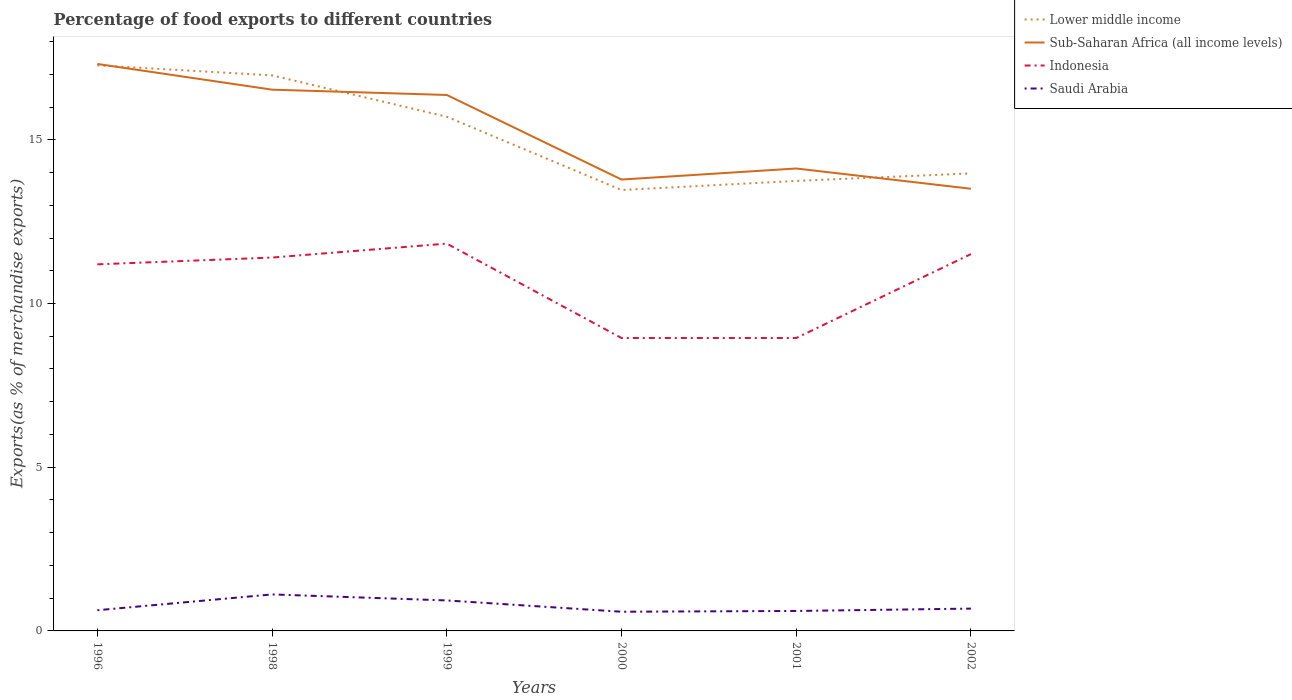Is the number of lines equal to the number of legend labels?
Offer a terse response. Yes. Across all years, what is the maximum percentage of exports to different countries in Indonesia?
Give a very brief answer. 8.95. In which year was the percentage of exports to different countries in Sub-Saharan Africa (all income levels) maximum?
Ensure brevity in your answer.  2002. What is the total percentage of exports to different countries in Sub-Saharan Africa (all income levels) in the graph?
Offer a very short reply. 3.19. What is the difference between the highest and the second highest percentage of exports to different countries in Lower middle income?
Ensure brevity in your answer.  3.81. Is the percentage of exports to different countries in Saudi Arabia strictly greater than the percentage of exports to different countries in Indonesia over the years?
Provide a short and direct response. Yes. How many lines are there?
Keep it short and to the point. 4. How many years are there in the graph?
Keep it short and to the point. 6. Are the values on the major ticks of Y-axis written in scientific E-notation?
Your answer should be very brief. No. Does the graph contain any zero values?
Offer a terse response. No. Does the graph contain grids?
Your response must be concise. No. Where does the legend appear in the graph?
Your answer should be compact. Top right. How many legend labels are there?
Provide a short and direct response. 4. How are the legend labels stacked?
Your response must be concise. Vertical. What is the title of the graph?
Provide a succinct answer. Percentage of food exports to different countries. Does "Tanzania" appear as one of the legend labels in the graph?
Give a very brief answer. No. What is the label or title of the Y-axis?
Keep it short and to the point. Exports(as % of merchandise exports). What is the Exports(as % of merchandise exports) of Lower middle income in 1996?
Keep it short and to the point. 17.27. What is the Exports(as % of merchandise exports) of Sub-Saharan Africa (all income levels) in 1996?
Give a very brief answer. 17.32. What is the Exports(as % of merchandise exports) in Indonesia in 1996?
Give a very brief answer. 11.2. What is the Exports(as % of merchandise exports) in Saudi Arabia in 1996?
Keep it short and to the point. 0.63. What is the Exports(as % of merchandise exports) of Lower middle income in 1998?
Offer a very short reply. 16.97. What is the Exports(as % of merchandise exports) in Sub-Saharan Africa (all income levels) in 1998?
Offer a terse response. 16.53. What is the Exports(as % of merchandise exports) of Indonesia in 1998?
Your answer should be very brief. 11.4. What is the Exports(as % of merchandise exports) of Saudi Arabia in 1998?
Provide a succinct answer. 1.11. What is the Exports(as % of merchandise exports) of Lower middle income in 1999?
Ensure brevity in your answer.  15.7. What is the Exports(as % of merchandise exports) of Sub-Saharan Africa (all income levels) in 1999?
Offer a very short reply. 16.37. What is the Exports(as % of merchandise exports) in Indonesia in 1999?
Provide a short and direct response. 11.83. What is the Exports(as % of merchandise exports) in Saudi Arabia in 1999?
Ensure brevity in your answer.  0.93. What is the Exports(as % of merchandise exports) in Lower middle income in 2000?
Your answer should be very brief. 13.47. What is the Exports(as % of merchandise exports) of Sub-Saharan Africa (all income levels) in 2000?
Provide a short and direct response. 13.79. What is the Exports(as % of merchandise exports) in Indonesia in 2000?
Provide a short and direct response. 8.95. What is the Exports(as % of merchandise exports) in Saudi Arabia in 2000?
Your response must be concise. 0.59. What is the Exports(as % of merchandise exports) of Lower middle income in 2001?
Ensure brevity in your answer.  13.74. What is the Exports(as % of merchandise exports) in Sub-Saharan Africa (all income levels) in 2001?
Provide a short and direct response. 14.12. What is the Exports(as % of merchandise exports) of Indonesia in 2001?
Make the answer very short. 8.95. What is the Exports(as % of merchandise exports) in Saudi Arabia in 2001?
Your answer should be very brief. 0.61. What is the Exports(as % of merchandise exports) in Lower middle income in 2002?
Give a very brief answer. 13.97. What is the Exports(as % of merchandise exports) in Sub-Saharan Africa (all income levels) in 2002?
Offer a very short reply. 13.5. What is the Exports(as % of merchandise exports) of Indonesia in 2002?
Your response must be concise. 11.51. What is the Exports(as % of merchandise exports) in Saudi Arabia in 2002?
Keep it short and to the point. 0.68. Across all years, what is the maximum Exports(as % of merchandise exports) of Lower middle income?
Ensure brevity in your answer.  17.27. Across all years, what is the maximum Exports(as % of merchandise exports) in Sub-Saharan Africa (all income levels)?
Offer a terse response. 17.32. Across all years, what is the maximum Exports(as % of merchandise exports) of Indonesia?
Ensure brevity in your answer.  11.83. Across all years, what is the maximum Exports(as % of merchandise exports) in Saudi Arabia?
Provide a succinct answer. 1.11. Across all years, what is the minimum Exports(as % of merchandise exports) of Lower middle income?
Your response must be concise. 13.47. Across all years, what is the minimum Exports(as % of merchandise exports) of Sub-Saharan Africa (all income levels)?
Offer a terse response. 13.5. Across all years, what is the minimum Exports(as % of merchandise exports) in Indonesia?
Keep it short and to the point. 8.95. Across all years, what is the minimum Exports(as % of merchandise exports) of Saudi Arabia?
Offer a very short reply. 0.59. What is the total Exports(as % of merchandise exports) of Lower middle income in the graph?
Your response must be concise. 91.13. What is the total Exports(as % of merchandise exports) in Sub-Saharan Africa (all income levels) in the graph?
Offer a very short reply. 91.63. What is the total Exports(as % of merchandise exports) in Indonesia in the graph?
Provide a succinct answer. 63.83. What is the total Exports(as % of merchandise exports) in Saudi Arabia in the graph?
Make the answer very short. 4.56. What is the difference between the Exports(as % of merchandise exports) in Lower middle income in 1996 and that in 1998?
Keep it short and to the point. 0.31. What is the difference between the Exports(as % of merchandise exports) of Sub-Saharan Africa (all income levels) in 1996 and that in 1998?
Give a very brief answer. 0.78. What is the difference between the Exports(as % of merchandise exports) of Indonesia in 1996 and that in 1998?
Provide a short and direct response. -0.21. What is the difference between the Exports(as % of merchandise exports) of Saudi Arabia in 1996 and that in 1998?
Your answer should be very brief. -0.48. What is the difference between the Exports(as % of merchandise exports) of Lower middle income in 1996 and that in 1999?
Your response must be concise. 1.57. What is the difference between the Exports(as % of merchandise exports) of Sub-Saharan Africa (all income levels) in 1996 and that in 1999?
Provide a succinct answer. 0.95. What is the difference between the Exports(as % of merchandise exports) of Indonesia in 1996 and that in 1999?
Offer a very short reply. -0.63. What is the difference between the Exports(as % of merchandise exports) in Saudi Arabia in 1996 and that in 1999?
Make the answer very short. -0.3. What is the difference between the Exports(as % of merchandise exports) of Lower middle income in 1996 and that in 2000?
Your answer should be compact. 3.81. What is the difference between the Exports(as % of merchandise exports) of Sub-Saharan Africa (all income levels) in 1996 and that in 2000?
Make the answer very short. 3.53. What is the difference between the Exports(as % of merchandise exports) in Indonesia in 1996 and that in 2000?
Keep it short and to the point. 2.25. What is the difference between the Exports(as % of merchandise exports) in Saudi Arabia in 1996 and that in 2000?
Offer a very short reply. 0.05. What is the difference between the Exports(as % of merchandise exports) of Lower middle income in 1996 and that in 2001?
Give a very brief answer. 3.53. What is the difference between the Exports(as % of merchandise exports) of Sub-Saharan Africa (all income levels) in 1996 and that in 2001?
Offer a terse response. 3.19. What is the difference between the Exports(as % of merchandise exports) of Indonesia in 1996 and that in 2001?
Provide a succinct answer. 2.25. What is the difference between the Exports(as % of merchandise exports) of Saudi Arabia in 1996 and that in 2001?
Make the answer very short. 0.02. What is the difference between the Exports(as % of merchandise exports) in Sub-Saharan Africa (all income levels) in 1996 and that in 2002?
Your response must be concise. 3.81. What is the difference between the Exports(as % of merchandise exports) in Indonesia in 1996 and that in 2002?
Provide a succinct answer. -0.31. What is the difference between the Exports(as % of merchandise exports) in Saudi Arabia in 1996 and that in 2002?
Your answer should be compact. -0.05. What is the difference between the Exports(as % of merchandise exports) in Lower middle income in 1998 and that in 1999?
Keep it short and to the point. 1.26. What is the difference between the Exports(as % of merchandise exports) in Sub-Saharan Africa (all income levels) in 1998 and that in 1999?
Ensure brevity in your answer.  0.16. What is the difference between the Exports(as % of merchandise exports) in Indonesia in 1998 and that in 1999?
Offer a terse response. -0.43. What is the difference between the Exports(as % of merchandise exports) in Saudi Arabia in 1998 and that in 1999?
Make the answer very short. 0.18. What is the difference between the Exports(as % of merchandise exports) in Lower middle income in 1998 and that in 2000?
Provide a short and direct response. 3.5. What is the difference between the Exports(as % of merchandise exports) of Sub-Saharan Africa (all income levels) in 1998 and that in 2000?
Ensure brevity in your answer.  2.75. What is the difference between the Exports(as % of merchandise exports) of Indonesia in 1998 and that in 2000?
Provide a succinct answer. 2.46. What is the difference between the Exports(as % of merchandise exports) in Saudi Arabia in 1998 and that in 2000?
Keep it short and to the point. 0.53. What is the difference between the Exports(as % of merchandise exports) in Lower middle income in 1998 and that in 2001?
Offer a very short reply. 3.22. What is the difference between the Exports(as % of merchandise exports) in Sub-Saharan Africa (all income levels) in 1998 and that in 2001?
Give a very brief answer. 2.41. What is the difference between the Exports(as % of merchandise exports) in Indonesia in 1998 and that in 2001?
Provide a succinct answer. 2.46. What is the difference between the Exports(as % of merchandise exports) in Saudi Arabia in 1998 and that in 2001?
Give a very brief answer. 0.51. What is the difference between the Exports(as % of merchandise exports) in Lower middle income in 1998 and that in 2002?
Offer a very short reply. 2.99. What is the difference between the Exports(as % of merchandise exports) in Sub-Saharan Africa (all income levels) in 1998 and that in 2002?
Your answer should be compact. 3.03. What is the difference between the Exports(as % of merchandise exports) of Indonesia in 1998 and that in 2002?
Your answer should be very brief. -0.11. What is the difference between the Exports(as % of merchandise exports) of Saudi Arabia in 1998 and that in 2002?
Your answer should be compact. 0.43. What is the difference between the Exports(as % of merchandise exports) of Lower middle income in 1999 and that in 2000?
Keep it short and to the point. 2.24. What is the difference between the Exports(as % of merchandise exports) of Sub-Saharan Africa (all income levels) in 1999 and that in 2000?
Offer a very short reply. 2.58. What is the difference between the Exports(as % of merchandise exports) of Indonesia in 1999 and that in 2000?
Make the answer very short. 2.88. What is the difference between the Exports(as % of merchandise exports) of Saudi Arabia in 1999 and that in 2000?
Offer a terse response. 0.34. What is the difference between the Exports(as % of merchandise exports) of Lower middle income in 1999 and that in 2001?
Provide a short and direct response. 1.96. What is the difference between the Exports(as % of merchandise exports) of Sub-Saharan Africa (all income levels) in 1999 and that in 2001?
Provide a short and direct response. 2.25. What is the difference between the Exports(as % of merchandise exports) in Indonesia in 1999 and that in 2001?
Your response must be concise. 2.88. What is the difference between the Exports(as % of merchandise exports) of Saudi Arabia in 1999 and that in 2001?
Your answer should be very brief. 0.32. What is the difference between the Exports(as % of merchandise exports) of Lower middle income in 1999 and that in 2002?
Your response must be concise. 1.73. What is the difference between the Exports(as % of merchandise exports) of Sub-Saharan Africa (all income levels) in 1999 and that in 2002?
Offer a very short reply. 2.86. What is the difference between the Exports(as % of merchandise exports) of Indonesia in 1999 and that in 2002?
Your response must be concise. 0.32. What is the difference between the Exports(as % of merchandise exports) of Saudi Arabia in 1999 and that in 2002?
Ensure brevity in your answer.  0.25. What is the difference between the Exports(as % of merchandise exports) of Lower middle income in 2000 and that in 2001?
Provide a short and direct response. -0.28. What is the difference between the Exports(as % of merchandise exports) in Sub-Saharan Africa (all income levels) in 2000 and that in 2001?
Give a very brief answer. -0.34. What is the difference between the Exports(as % of merchandise exports) in Indonesia in 2000 and that in 2001?
Your answer should be compact. -0. What is the difference between the Exports(as % of merchandise exports) in Saudi Arabia in 2000 and that in 2001?
Your answer should be very brief. -0.02. What is the difference between the Exports(as % of merchandise exports) in Lower middle income in 2000 and that in 2002?
Your response must be concise. -0.51. What is the difference between the Exports(as % of merchandise exports) of Sub-Saharan Africa (all income levels) in 2000 and that in 2002?
Offer a very short reply. 0.28. What is the difference between the Exports(as % of merchandise exports) of Indonesia in 2000 and that in 2002?
Make the answer very short. -2.56. What is the difference between the Exports(as % of merchandise exports) of Saudi Arabia in 2000 and that in 2002?
Provide a succinct answer. -0.1. What is the difference between the Exports(as % of merchandise exports) of Lower middle income in 2001 and that in 2002?
Your response must be concise. -0.23. What is the difference between the Exports(as % of merchandise exports) of Sub-Saharan Africa (all income levels) in 2001 and that in 2002?
Your response must be concise. 0.62. What is the difference between the Exports(as % of merchandise exports) of Indonesia in 2001 and that in 2002?
Your answer should be compact. -2.56. What is the difference between the Exports(as % of merchandise exports) in Saudi Arabia in 2001 and that in 2002?
Keep it short and to the point. -0.07. What is the difference between the Exports(as % of merchandise exports) in Lower middle income in 1996 and the Exports(as % of merchandise exports) in Sub-Saharan Africa (all income levels) in 1998?
Your answer should be compact. 0.74. What is the difference between the Exports(as % of merchandise exports) of Lower middle income in 1996 and the Exports(as % of merchandise exports) of Indonesia in 1998?
Ensure brevity in your answer.  5.87. What is the difference between the Exports(as % of merchandise exports) in Lower middle income in 1996 and the Exports(as % of merchandise exports) in Saudi Arabia in 1998?
Make the answer very short. 16.16. What is the difference between the Exports(as % of merchandise exports) of Sub-Saharan Africa (all income levels) in 1996 and the Exports(as % of merchandise exports) of Indonesia in 1998?
Offer a terse response. 5.91. What is the difference between the Exports(as % of merchandise exports) of Sub-Saharan Africa (all income levels) in 1996 and the Exports(as % of merchandise exports) of Saudi Arabia in 1998?
Provide a short and direct response. 16.2. What is the difference between the Exports(as % of merchandise exports) of Indonesia in 1996 and the Exports(as % of merchandise exports) of Saudi Arabia in 1998?
Provide a succinct answer. 10.08. What is the difference between the Exports(as % of merchandise exports) in Lower middle income in 1996 and the Exports(as % of merchandise exports) in Sub-Saharan Africa (all income levels) in 1999?
Provide a short and direct response. 0.9. What is the difference between the Exports(as % of merchandise exports) of Lower middle income in 1996 and the Exports(as % of merchandise exports) of Indonesia in 1999?
Offer a very short reply. 5.44. What is the difference between the Exports(as % of merchandise exports) of Lower middle income in 1996 and the Exports(as % of merchandise exports) of Saudi Arabia in 1999?
Ensure brevity in your answer.  16.34. What is the difference between the Exports(as % of merchandise exports) in Sub-Saharan Africa (all income levels) in 1996 and the Exports(as % of merchandise exports) in Indonesia in 1999?
Provide a succinct answer. 5.49. What is the difference between the Exports(as % of merchandise exports) in Sub-Saharan Africa (all income levels) in 1996 and the Exports(as % of merchandise exports) in Saudi Arabia in 1999?
Provide a succinct answer. 16.38. What is the difference between the Exports(as % of merchandise exports) of Indonesia in 1996 and the Exports(as % of merchandise exports) of Saudi Arabia in 1999?
Make the answer very short. 10.26. What is the difference between the Exports(as % of merchandise exports) in Lower middle income in 1996 and the Exports(as % of merchandise exports) in Sub-Saharan Africa (all income levels) in 2000?
Make the answer very short. 3.49. What is the difference between the Exports(as % of merchandise exports) in Lower middle income in 1996 and the Exports(as % of merchandise exports) in Indonesia in 2000?
Provide a short and direct response. 8.33. What is the difference between the Exports(as % of merchandise exports) of Lower middle income in 1996 and the Exports(as % of merchandise exports) of Saudi Arabia in 2000?
Your answer should be compact. 16.69. What is the difference between the Exports(as % of merchandise exports) in Sub-Saharan Africa (all income levels) in 1996 and the Exports(as % of merchandise exports) in Indonesia in 2000?
Offer a terse response. 8.37. What is the difference between the Exports(as % of merchandise exports) of Sub-Saharan Africa (all income levels) in 1996 and the Exports(as % of merchandise exports) of Saudi Arabia in 2000?
Give a very brief answer. 16.73. What is the difference between the Exports(as % of merchandise exports) of Indonesia in 1996 and the Exports(as % of merchandise exports) of Saudi Arabia in 2000?
Keep it short and to the point. 10.61. What is the difference between the Exports(as % of merchandise exports) in Lower middle income in 1996 and the Exports(as % of merchandise exports) in Sub-Saharan Africa (all income levels) in 2001?
Provide a short and direct response. 3.15. What is the difference between the Exports(as % of merchandise exports) in Lower middle income in 1996 and the Exports(as % of merchandise exports) in Indonesia in 2001?
Your answer should be very brief. 8.33. What is the difference between the Exports(as % of merchandise exports) in Lower middle income in 1996 and the Exports(as % of merchandise exports) in Saudi Arabia in 2001?
Keep it short and to the point. 16.66. What is the difference between the Exports(as % of merchandise exports) in Sub-Saharan Africa (all income levels) in 1996 and the Exports(as % of merchandise exports) in Indonesia in 2001?
Your answer should be very brief. 8.37. What is the difference between the Exports(as % of merchandise exports) of Sub-Saharan Africa (all income levels) in 1996 and the Exports(as % of merchandise exports) of Saudi Arabia in 2001?
Make the answer very short. 16.71. What is the difference between the Exports(as % of merchandise exports) of Indonesia in 1996 and the Exports(as % of merchandise exports) of Saudi Arabia in 2001?
Provide a succinct answer. 10.59. What is the difference between the Exports(as % of merchandise exports) of Lower middle income in 1996 and the Exports(as % of merchandise exports) of Sub-Saharan Africa (all income levels) in 2002?
Give a very brief answer. 3.77. What is the difference between the Exports(as % of merchandise exports) in Lower middle income in 1996 and the Exports(as % of merchandise exports) in Indonesia in 2002?
Ensure brevity in your answer.  5.76. What is the difference between the Exports(as % of merchandise exports) of Lower middle income in 1996 and the Exports(as % of merchandise exports) of Saudi Arabia in 2002?
Offer a terse response. 16.59. What is the difference between the Exports(as % of merchandise exports) in Sub-Saharan Africa (all income levels) in 1996 and the Exports(as % of merchandise exports) in Indonesia in 2002?
Provide a short and direct response. 5.81. What is the difference between the Exports(as % of merchandise exports) in Sub-Saharan Africa (all income levels) in 1996 and the Exports(as % of merchandise exports) in Saudi Arabia in 2002?
Make the answer very short. 16.63. What is the difference between the Exports(as % of merchandise exports) in Indonesia in 1996 and the Exports(as % of merchandise exports) in Saudi Arabia in 2002?
Give a very brief answer. 10.51. What is the difference between the Exports(as % of merchandise exports) of Lower middle income in 1998 and the Exports(as % of merchandise exports) of Sub-Saharan Africa (all income levels) in 1999?
Offer a terse response. 0.6. What is the difference between the Exports(as % of merchandise exports) of Lower middle income in 1998 and the Exports(as % of merchandise exports) of Indonesia in 1999?
Ensure brevity in your answer.  5.14. What is the difference between the Exports(as % of merchandise exports) in Lower middle income in 1998 and the Exports(as % of merchandise exports) in Saudi Arabia in 1999?
Give a very brief answer. 16.04. What is the difference between the Exports(as % of merchandise exports) in Sub-Saharan Africa (all income levels) in 1998 and the Exports(as % of merchandise exports) in Indonesia in 1999?
Provide a short and direct response. 4.7. What is the difference between the Exports(as % of merchandise exports) in Sub-Saharan Africa (all income levels) in 1998 and the Exports(as % of merchandise exports) in Saudi Arabia in 1999?
Offer a terse response. 15.6. What is the difference between the Exports(as % of merchandise exports) of Indonesia in 1998 and the Exports(as % of merchandise exports) of Saudi Arabia in 1999?
Keep it short and to the point. 10.47. What is the difference between the Exports(as % of merchandise exports) in Lower middle income in 1998 and the Exports(as % of merchandise exports) in Sub-Saharan Africa (all income levels) in 2000?
Offer a very short reply. 3.18. What is the difference between the Exports(as % of merchandise exports) in Lower middle income in 1998 and the Exports(as % of merchandise exports) in Indonesia in 2000?
Offer a terse response. 8.02. What is the difference between the Exports(as % of merchandise exports) of Lower middle income in 1998 and the Exports(as % of merchandise exports) of Saudi Arabia in 2000?
Your answer should be compact. 16.38. What is the difference between the Exports(as % of merchandise exports) of Sub-Saharan Africa (all income levels) in 1998 and the Exports(as % of merchandise exports) of Indonesia in 2000?
Provide a short and direct response. 7.58. What is the difference between the Exports(as % of merchandise exports) of Sub-Saharan Africa (all income levels) in 1998 and the Exports(as % of merchandise exports) of Saudi Arabia in 2000?
Your response must be concise. 15.94. What is the difference between the Exports(as % of merchandise exports) in Indonesia in 1998 and the Exports(as % of merchandise exports) in Saudi Arabia in 2000?
Your response must be concise. 10.82. What is the difference between the Exports(as % of merchandise exports) in Lower middle income in 1998 and the Exports(as % of merchandise exports) in Sub-Saharan Africa (all income levels) in 2001?
Give a very brief answer. 2.84. What is the difference between the Exports(as % of merchandise exports) in Lower middle income in 1998 and the Exports(as % of merchandise exports) in Indonesia in 2001?
Your response must be concise. 8.02. What is the difference between the Exports(as % of merchandise exports) of Lower middle income in 1998 and the Exports(as % of merchandise exports) of Saudi Arabia in 2001?
Make the answer very short. 16.36. What is the difference between the Exports(as % of merchandise exports) of Sub-Saharan Africa (all income levels) in 1998 and the Exports(as % of merchandise exports) of Indonesia in 2001?
Your answer should be compact. 7.58. What is the difference between the Exports(as % of merchandise exports) in Sub-Saharan Africa (all income levels) in 1998 and the Exports(as % of merchandise exports) in Saudi Arabia in 2001?
Your response must be concise. 15.92. What is the difference between the Exports(as % of merchandise exports) in Indonesia in 1998 and the Exports(as % of merchandise exports) in Saudi Arabia in 2001?
Give a very brief answer. 10.79. What is the difference between the Exports(as % of merchandise exports) in Lower middle income in 1998 and the Exports(as % of merchandise exports) in Sub-Saharan Africa (all income levels) in 2002?
Your answer should be compact. 3.46. What is the difference between the Exports(as % of merchandise exports) in Lower middle income in 1998 and the Exports(as % of merchandise exports) in Indonesia in 2002?
Offer a terse response. 5.46. What is the difference between the Exports(as % of merchandise exports) of Lower middle income in 1998 and the Exports(as % of merchandise exports) of Saudi Arabia in 2002?
Keep it short and to the point. 16.29. What is the difference between the Exports(as % of merchandise exports) of Sub-Saharan Africa (all income levels) in 1998 and the Exports(as % of merchandise exports) of Indonesia in 2002?
Give a very brief answer. 5.02. What is the difference between the Exports(as % of merchandise exports) in Sub-Saharan Africa (all income levels) in 1998 and the Exports(as % of merchandise exports) in Saudi Arabia in 2002?
Offer a terse response. 15.85. What is the difference between the Exports(as % of merchandise exports) of Indonesia in 1998 and the Exports(as % of merchandise exports) of Saudi Arabia in 2002?
Give a very brief answer. 10.72. What is the difference between the Exports(as % of merchandise exports) of Lower middle income in 1999 and the Exports(as % of merchandise exports) of Sub-Saharan Africa (all income levels) in 2000?
Offer a terse response. 1.92. What is the difference between the Exports(as % of merchandise exports) of Lower middle income in 1999 and the Exports(as % of merchandise exports) of Indonesia in 2000?
Keep it short and to the point. 6.76. What is the difference between the Exports(as % of merchandise exports) in Lower middle income in 1999 and the Exports(as % of merchandise exports) in Saudi Arabia in 2000?
Offer a terse response. 15.12. What is the difference between the Exports(as % of merchandise exports) in Sub-Saharan Africa (all income levels) in 1999 and the Exports(as % of merchandise exports) in Indonesia in 2000?
Keep it short and to the point. 7.42. What is the difference between the Exports(as % of merchandise exports) of Sub-Saharan Africa (all income levels) in 1999 and the Exports(as % of merchandise exports) of Saudi Arabia in 2000?
Make the answer very short. 15.78. What is the difference between the Exports(as % of merchandise exports) of Indonesia in 1999 and the Exports(as % of merchandise exports) of Saudi Arabia in 2000?
Offer a very short reply. 11.24. What is the difference between the Exports(as % of merchandise exports) in Lower middle income in 1999 and the Exports(as % of merchandise exports) in Sub-Saharan Africa (all income levels) in 2001?
Make the answer very short. 1.58. What is the difference between the Exports(as % of merchandise exports) in Lower middle income in 1999 and the Exports(as % of merchandise exports) in Indonesia in 2001?
Offer a terse response. 6.76. What is the difference between the Exports(as % of merchandise exports) in Lower middle income in 1999 and the Exports(as % of merchandise exports) in Saudi Arabia in 2001?
Offer a very short reply. 15.09. What is the difference between the Exports(as % of merchandise exports) in Sub-Saharan Africa (all income levels) in 1999 and the Exports(as % of merchandise exports) in Indonesia in 2001?
Your response must be concise. 7.42. What is the difference between the Exports(as % of merchandise exports) of Sub-Saharan Africa (all income levels) in 1999 and the Exports(as % of merchandise exports) of Saudi Arabia in 2001?
Offer a very short reply. 15.76. What is the difference between the Exports(as % of merchandise exports) in Indonesia in 1999 and the Exports(as % of merchandise exports) in Saudi Arabia in 2001?
Offer a very short reply. 11.22. What is the difference between the Exports(as % of merchandise exports) of Lower middle income in 1999 and the Exports(as % of merchandise exports) of Sub-Saharan Africa (all income levels) in 2002?
Offer a terse response. 2.2. What is the difference between the Exports(as % of merchandise exports) in Lower middle income in 1999 and the Exports(as % of merchandise exports) in Indonesia in 2002?
Your answer should be compact. 4.19. What is the difference between the Exports(as % of merchandise exports) of Lower middle income in 1999 and the Exports(as % of merchandise exports) of Saudi Arabia in 2002?
Provide a succinct answer. 15.02. What is the difference between the Exports(as % of merchandise exports) in Sub-Saharan Africa (all income levels) in 1999 and the Exports(as % of merchandise exports) in Indonesia in 2002?
Offer a terse response. 4.86. What is the difference between the Exports(as % of merchandise exports) of Sub-Saharan Africa (all income levels) in 1999 and the Exports(as % of merchandise exports) of Saudi Arabia in 2002?
Give a very brief answer. 15.69. What is the difference between the Exports(as % of merchandise exports) in Indonesia in 1999 and the Exports(as % of merchandise exports) in Saudi Arabia in 2002?
Provide a succinct answer. 11.15. What is the difference between the Exports(as % of merchandise exports) in Lower middle income in 2000 and the Exports(as % of merchandise exports) in Sub-Saharan Africa (all income levels) in 2001?
Your response must be concise. -0.66. What is the difference between the Exports(as % of merchandise exports) in Lower middle income in 2000 and the Exports(as % of merchandise exports) in Indonesia in 2001?
Make the answer very short. 4.52. What is the difference between the Exports(as % of merchandise exports) in Lower middle income in 2000 and the Exports(as % of merchandise exports) in Saudi Arabia in 2001?
Provide a short and direct response. 12.86. What is the difference between the Exports(as % of merchandise exports) of Sub-Saharan Africa (all income levels) in 2000 and the Exports(as % of merchandise exports) of Indonesia in 2001?
Give a very brief answer. 4.84. What is the difference between the Exports(as % of merchandise exports) in Sub-Saharan Africa (all income levels) in 2000 and the Exports(as % of merchandise exports) in Saudi Arabia in 2001?
Keep it short and to the point. 13.18. What is the difference between the Exports(as % of merchandise exports) in Indonesia in 2000 and the Exports(as % of merchandise exports) in Saudi Arabia in 2001?
Offer a very short reply. 8.34. What is the difference between the Exports(as % of merchandise exports) in Lower middle income in 2000 and the Exports(as % of merchandise exports) in Sub-Saharan Africa (all income levels) in 2002?
Your response must be concise. -0.04. What is the difference between the Exports(as % of merchandise exports) of Lower middle income in 2000 and the Exports(as % of merchandise exports) of Indonesia in 2002?
Your answer should be compact. 1.96. What is the difference between the Exports(as % of merchandise exports) in Lower middle income in 2000 and the Exports(as % of merchandise exports) in Saudi Arabia in 2002?
Provide a short and direct response. 12.78. What is the difference between the Exports(as % of merchandise exports) of Sub-Saharan Africa (all income levels) in 2000 and the Exports(as % of merchandise exports) of Indonesia in 2002?
Your answer should be very brief. 2.28. What is the difference between the Exports(as % of merchandise exports) of Sub-Saharan Africa (all income levels) in 2000 and the Exports(as % of merchandise exports) of Saudi Arabia in 2002?
Offer a terse response. 13.1. What is the difference between the Exports(as % of merchandise exports) in Indonesia in 2000 and the Exports(as % of merchandise exports) in Saudi Arabia in 2002?
Your answer should be very brief. 8.26. What is the difference between the Exports(as % of merchandise exports) in Lower middle income in 2001 and the Exports(as % of merchandise exports) in Sub-Saharan Africa (all income levels) in 2002?
Give a very brief answer. 0.24. What is the difference between the Exports(as % of merchandise exports) in Lower middle income in 2001 and the Exports(as % of merchandise exports) in Indonesia in 2002?
Keep it short and to the point. 2.23. What is the difference between the Exports(as % of merchandise exports) in Lower middle income in 2001 and the Exports(as % of merchandise exports) in Saudi Arabia in 2002?
Offer a terse response. 13.06. What is the difference between the Exports(as % of merchandise exports) of Sub-Saharan Africa (all income levels) in 2001 and the Exports(as % of merchandise exports) of Indonesia in 2002?
Your answer should be very brief. 2.61. What is the difference between the Exports(as % of merchandise exports) in Sub-Saharan Africa (all income levels) in 2001 and the Exports(as % of merchandise exports) in Saudi Arabia in 2002?
Offer a very short reply. 13.44. What is the difference between the Exports(as % of merchandise exports) in Indonesia in 2001 and the Exports(as % of merchandise exports) in Saudi Arabia in 2002?
Keep it short and to the point. 8.26. What is the average Exports(as % of merchandise exports) of Lower middle income per year?
Ensure brevity in your answer.  15.19. What is the average Exports(as % of merchandise exports) in Sub-Saharan Africa (all income levels) per year?
Your answer should be compact. 15.27. What is the average Exports(as % of merchandise exports) of Indonesia per year?
Provide a succinct answer. 10.64. What is the average Exports(as % of merchandise exports) in Saudi Arabia per year?
Offer a terse response. 0.76. In the year 1996, what is the difference between the Exports(as % of merchandise exports) of Lower middle income and Exports(as % of merchandise exports) of Sub-Saharan Africa (all income levels)?
Ensure brevity in your answer.  -0.04. In the year 1996, what is the difference between the Exports(as % of merchandise exports) of Lower middle income and Exports(as % of merchandise exports) of Indonesia?
Provide a short and direct response. 6.08. In the year 1996, what is the difference between the Exports(as % of merchandise exports) of Lower middle income and Exports(as % of merchandise exports) of Saudi Arabia?
Offer a terse response. 16.64. In the year 1996, what is the difference between the Exports(as % of merchandise exports) in Sub-Saharan Africa (all income levels) and Exports(as % of merchandise exports) in Indonesia?
Make the answer very short. 6.12. In the year 1996, what is the difference between the Exports(as % of merchandise exports) in Sub-Saharan Africa (all income levels) and Exports(as % of merchandise exports) in Saudi Arabia?
Make the answer very short. 16.68. In the year 1996, what is the difference between the Exports(as % of merchandise exports) in Indonesia and Exports(as % of merchandise exports) in Saudi Arabia?
Make the answer very short. 10.56. In the year 1998, what is the difference between the Exports(as % of merchandise exports) of Lower middle income and Exports(as % of merchandise exports) of Sub-Saharan Africa (all income levels)?
Your answer should be very brief. 0.44. In the year 1998, what is the difference between the Exports(as % of merchandise exports) of Lower middle income and Exports(as % of merchandise exports) of Indonesia?
Offer a very short reply. 5.56. In the year 1998, what is the difference between the Exports(as % of merchandise exports) of Lower middle income and Exports(as % of merchandise exports) of Saudi Arabia?
Keep it short and to the point. 15.85. In the year 1998, what is the difference between the Exports(as % of merchandise exports) in Sub-Saharan Africa (all income levels) and Exports(as % of merchandise exports) in Indonesia?
Keep it short and to the point. 5.13. In the year 1998, what is the difference between the Exports(as % of merchandise exports) in Sub-Saharan Africa (all income levels) and Exports(as % of merchandise exports) in Saudi Arabia?
Offer a terse response. 15.42. In the year 1998, what is the difference between the Exports(as % of merchandise exports) of Indonesia and Exports(as % of merchandise exports) of Saudi Arabia?
Ensure brevity in your answer.  10.29. In the year 1999, what is the difference between the Exports(as % of merchandise exports) in Lower middle income and Exports(as % of merchandise exports) in Sub-Saharan Africa (all income levels)?
Provide a succinct answer. -0.67. In the year 1999, what is the difference between the Exports(as % of merchandise exports) in Lower middle income and Exports(as % of merchandise exports) in Indonesia?
Your answer should be very brief. 3.87. In the year 1999, what is the difference between the Exports(as % of merchandise exports) of Lower middle income and Exports(as % of merchandise exports) of Saudi Arabia?
Offer a terse response. 14.77. In the year 1999, what is the difference between the Exports(as % of merchandise exports) of Sub-Saharan Africa (all income levels) and Exports(as % of merchandise exports) of Indonesia?
Ensure brevity in your answer.  4.54. In the year 1999, what is the difference between the Exports(as % of merchandise exports) of Sub-Saharan Africa (all income levels) and Exports(as % of merchandise exports) of Saudi Arabia?
Make the answer very short. 15.44. In the year 1999, what is the difference between the Exports(as % of merchandise exports) in Indonesia and Exports(as % of merchandise exports) in Saudi Arabia?
Ensure brevity in your answer.  10.9. In the year 2000, what is the difference between the Exports(as % of merchandise exports) in Lower middle income and Exports(as % of merchandise exports) in Sub-Saharan Africa (all income levels)?
Offer a very short reply. -0.32. In the year 2000, what is the difference between the Exports(as % of merchandise exports) in Lower middle income and Exports(as % of merchandise exports) in Indonesia?
Make the answer very short. 4.52. In the year 2000, what is the difference between the Exports(as % of merchandise exports) in Lower middle income and Exports(as % of merchandise exports) in Saudi Arabia?
Make the answer very short. 12.88. In the year 2000, what is the difference between the Exports(as % of merchandise exports) in Sub-Saharan Africa (all income levels) and Exports(as % of merchandise exports) in Indonesia?
Provide a short and direct response. 4.84. In the year 2000, what is the difference between the Exports(as % of merchandise exports) in Sub-Saharan Africa (all income levels) and Exports(as % of merchandise exports) in Saudi Arabia?
Your response must be concise. 13.2. In the year 2000, what is the difference between the Exports(as % of merchandise exports) of Indonesia and Exports(as % of merchandise exports) of Saudi Arabia?
Your response must be concise. 8.36. In the year 2001, what is the difference between the Exports(as % of merchandise exports) of Lower middle income and Exports(as % of merchandise exports) of Sub-Saharan Africa (all income levels)?
Provide a succinct answer. -0.38. In the year 2001, what is the difference between the Exports(as % of merchandise exports) in Lower middle income and Exports(as % of merchandise exports) in Indonesia?
Your response must be concise. 4.8. In the year 2001, what is the difference between the Exports(as % of merchandise exports) of Lower middle income and Exports(as % of merchandise exports) of Saudi Arabia?
Offer a terse response. 13.13. In the year 2001, what is the difference between the Exports(as % of merchandise exports) in Sub-Saharan Africa (all income levels) and Exports(as % of merchandise exports) in Indonesia?
Make the answer very short. 5.18. In the year 2001, what is the difference between the Exports(as % of merchandise exports) in Sub-Saharan Africa (all income levels) and Exports(as % of merchandise exports) in Saudi Arabia?
Your answer should be very brief. 13.51. In the year 2001, what is the difference between the Exports(as % of merchandise exports) in Indonesia and Exports(as % of merchandise exports) in Saudi Arabia?
Ensure brevity in your answer.  8.34. In the year 2002, what is the difference between the Exports(as % of merchandise exports) of Lower middle income and Exports(as % of merchandise exports) of Sub-Saharan Africa (all income levels)?
Offer a very short reply. 0.47. In the year 2002, what is the difference between the Exports(as % of merchandise exports) of Lower middle income and Exports(as % of merchandise exports) of Indonesia?
Your response must be concise. 2.46. In the year 2002, what is the difference between the Exports(as % of merchandise exports) of Lower middle income and Exports(as % of merchandise exports) of Saudi Arabia?
Give a very brief answer. 13.29. In the year 2002, what is the difference between the Exports(as % of merchandise exports) in Sub-Saharan Africa (all income levels) and Exports(as % of merchandise exports) in Indonesia?
Give a very brief answer. 2. In the year 2002, what is the difference between the Exports(as % of merchandise exports) of Sub-Saharan Africa (all income levels) and Exports(as % of merchandise exports) of Saudi Arabia?
Offer a very short reply. 12.82. In the year 2002, what is the difference between the Exports(as % of merchandise exports) in Indonesia and Exports(as % of merchandise exports) in Saudi Arabia?
Ensure brevity in your answer.  10.83. What is the ratio of the Exports(as % of merchandise exports) of Lower middle income in 1996 to that in 1998?
Ensure brevity in your answer.  1.02. What is the ratio of the Exports(as % of merchandise exports) in Sub-Saharan Africa (all income levels) in 1996 to that in 1998?
Your response must be concise. 1.05. What is the ratio of the Exports(as % of merchandise exports) of Indonesia in 1996 to that in 1998?
Provide a short and direct response. 0.98. What is the ratio of the Exports(as % of merchandise exports) of Saudi Arabia in 1996 to that in 1998?
Provide a succinct answer. 0.57. What is the ratio of the Exports(as % of merchandise exports) in Lower middle income in 1996 to that in 1999?
Offer a terse response. 1.1. What is the ratio of the Exports(as % of merchandise exports) of Sub-Saharan Africa (all income levels) in 1996 to that in 1999?
Keep it short and to the point. 1.06. What is the ratio of the Exports(as % of merchandise exports) of Indonesia in 1996 to that in 1999?
Make the answer very short. 0.95. What is the ratio of the Exports(as % of merchandise exports) in Saudi Arabia in 1996 to that in 1999?
Ensure brevity in your answer.  0.68. What is the ratio of the Exports(as % of merchandise exports) of Lower middle income in 1996 to that in 2000?
Ensure brevity in your answer.  1.28. What is the ratio of the Exports(as % of merchandise exports) of Sub-Saharan Africa (all income levels) in 1996 to that in 2000?
Your answer should be very brief. 1.26. What is the ratio of the Exports(as % of merchandise exports) of Indonesia in 1996 to that in 2000?
Ensure brevity in your answer.  1.25. What is the ratio of the Exports(as % of merchandise exports) of Saudi Arabia in 1996 to that in 2000?
Your answer should be very brief. 1.08. What is the ratio of the Exports(as % of merchandise exports) in Lower middle income in 1996 to that in 2001?
Your answer should be very brief. 1.26. What is the ratio of the Exports(as % of merchandise exports) of Sub-Saharan Africa (all income levels) in 1996 to that in 2001?
Keep it short and to the point. 1.23. What is the ratio of the Exports(as % of merchandise exports) of Indonesia in 1996 to that in 2001?
Give a very brief answer. 1.25. What is the ratio of the Exports(as % of merchandise exports) of Saudi Arabia in 1996 to that in 2001?
Give a very brief answer. 1.04. What is the ratio of the Exports(as % of merchandise exports) in Lower middle income in 1996 to that in 2002?
Offer a very short reply. 1.24. What is the ratio of the Exports(as % of merchandise exports) of Sub-Saharan Africa (all income levels) in 1996 to that in 2002?
Provide a short and direct response. 1.28. What is the ratio of the Exports(as % of merchandise exports) in Indonesia in 1996 to that in 2002?
Make the answer very short. 0.97. What is the ratio of the Exports(as % of merchandise exports) in Saudi Arabia in 1996 to that in 2002?
Keep it short and to the point. 0.93. What is the ratio of the Exports(as % of merchandise exports) of Lower middle income in 1998 to that in 1999?
Give a very brief answer. 1.08. What is the ratio of the Exports(as % of merchandise exports) in Sub-Saharan Africa (all income levels) in 1998 to that in 1999?
Keep it short and to the point. 1.01. What is the ratio of the Exports(as % of merchandise exports) of Indonesia in 1998 to that in 1999?
Your response must be concise. 0.96. What is the ratio of the Exports(as % of merchandise exports) in Saudi Arabia in 1998 to that in 1999?
Make the answer very short. 1.2. What is the ratio of the Exports(as % of merchandise exports) of Lower middle income in 1998 to that in 2000?
Offer a terse response. 1.26. What is the ratio of the Exports(as % of merchandise exports) of Sub-Saharan Africa (all income levels) in 1998 to that in 2000?
Your answer should be very brief. 1.2. What is the ratio of the Exports(as % of merchandise exports) of Indonesia in 1998 to that in 2000?
Keep it short and to the point. 1.27. What is the ratio of the Exports(as % of merchandise exports) of Saudi Arabia in 1998 to that in 2000?
Your answer should be compact. 1.9. What is the ratio of the Exports(as % of merchandise exports) in Lower middle income in 1998 to that in 2001?
Offer a very short reply. 1.23. What is the ratio of the Exports(as % of merchandise exports) in Sub-Saharan Africa (all income levels) in 1998 to that in 2001?
Make the answer very short. 1.17. What is the ratio of the Exports(as % of merchandise exports) of Indonesia in 1998 to that in 2001?
Your response must be concise. 1.27. What is the ratio of the Exports(as % of merchandise exports) of Saudi Arabia in 1998 to that in 2001?
Provide a short and direct response. 1.83. What is the ratio of the Exports(as % of merchandise exports) in Lower middle income in 1998 to that in 2002?
Your response must be concise. 1.21. What is the ratio of the Exports(as % of merchandise exports) in Sub-Saharan Africa (all income levels) in 1998 to that in 2002?
Ensure brevity in your answer.  1.22. What is the ratio of the Exports(as % of merchandise exports) in Saudi Arabia in 1998 to that in 2002?
Your answer should be compact. 1.64. What is the ratio of the Exports(as % of merchandise exports) of Lower middle income in 1999 to that in 2000?
Provide a short and direct response. 1.17. What is the ratio of the Exports(as % of merchandise exports) of Sub-Saharan Africa (all income levels) in 1999 to that in 2000?
Keep it short and to the point. 1.19. What is the ratio of the Exports(as % of merchandise exports) in Indonesia in 1999 to that in 2000?
Make the answer very short. 1.32. What is the ratio of the Exports(as % of merchandise exports) of Saudi Arabia in 1999 to that in 2000?
Provide a short and direct response. 1.59. What is the ratio of the Exports(as % of merchandise exports) of Lower middle income in 1999 to that in 2001?
Ensure brevity in your answer.  1.14. What is the ratio of the Exports(as % of merchandise exports) of Sub-Saharan Africa (all income levels) in 1999 to that in 2001?
Keep it short and to the point. 1.16. What is the ratio of the Exports(as % of merchandise exports) of Indonesia in 1999 to that in 2001?
Keep it short and to the point. 1.32. What is the ratio of the Exports(as % of merchandise exports) of Saudi Arabia in 1999 to that in 2001?
Ensure brevity in your answer.  1.53. What is the ratio of the Exports(as % of merchandise exports) in Lower middle income in 1999 to that in 2002?
Provide a short and direct response. 1.12. What is the ratio of the Exports(as % of merchandise exports) of Sub-Saharan Africa (all income levels) in 1999 to that in 2002?
Your answer should be compact. 1.21. What is the ratio of the Exports(as % of merchandise exports) of Indonesia in 1999 to that in 2002?
Ensure brevity in your answer.  1.03. What is the ratio of the Exports(as % of merchandise exports) of Saudi Arabia in 1999 to that in 2002?
Keep it short and to the point. 1.37. What is the ratio of the Exports(as % of merchandise exports) in Lower middle income in 2000 to that in 2001?
Offer a very short reply. 0.98. What is the ratio of the Exports(as % of merchandise exports) of Sub-Saharan Africa (all income levels) in 2000 to that in 2001?
Your response must be concise. 0.98. What is the ratio of the Exports(as % of merchandise exports) of Indonesia in 2000 to that in 2001?
Your answer should be very brief. 1. What is the ratio of the Exports(as % of merchandise exports) in Saudi Arabia in 2000 to that in 2001?
Provide a succinct answer. 0.96. What is the ratio of the Exports(as % of merchandise exports) of Lower middle income in 2000 to that in 2002?
Give a very brief answer. 0.96. What is the ratio of the Exports(as % of merchandise exports) of Sub-Saharan Africa (all income levels) in 2000 to that in 2002?
Offer a terse response. 1.02. What is the ratio of the Exports(as % of merchandise exports) in Indonesia in 2000 to that in 2002?
Make the answer very short. 0.78. What is the ratio of the Exports(as % of merchandise exports) of Saudi Arabia in 2000 to that in 2002?
Keep it short and to the point. 0.86. What is the ratio of the Exports(as % of merchandise exports) in Lower middle income in 2001 to that in 2002?
Your answer should be compact. 0.98. What is the ratio of the Exports(as % of merchandise exports) of Sub-Saharan Africa (all income levels) in 2001 to that in 2002?
Offer a terse response. 1.05. What is the ratio of the Exports(as % of merchandise exports) in Indonesia in 2001 to that in 2002?
Your response must be concise. 0.78. What is the ratio of the Exports(as % of merchandise exports) of Saudi Arabia in 2001 to that in 2002?
Provide a short and direct response. 0.89. What is the difference between the highest and the second highest Exports(as % of merchandise exports) of Lower middle income?
Offer a terse response. 0.31. What is the difference between the highest and the second highest Exports(as % of merchandise exports) of Sub-Saharan Africa (all income levels)?
Your answer should be compact. 0.78. What is the difference between the highest and the second highest Exports(as % of merchandise exports) of Indonesia?
Provide a short and direct response. 0.32. What is the difference between the highest and the second highest Exports(as % of merchandise exports) of Saudi Arabia?
Your response must be concise. 0.18. What is the difference between the highest and the lowest Exports(as % of merchandise exports) in Lower middle income?
Offer a very short reply. 3.81. What is the difference between the highest and the lowest Exports(as % of merchandise exports) of Sub-Saharan Africa (all income levels)?
Offer a terse response. 3.81. What is the difference between the highest and the lowest Exports(as % of merchandise exports) of Indonesia?
Offer a very short reply. 2.88. What is the difference between the highest and the lowest Exports(as % of merchandise exports) of Saudi Arabia?
Make the answer very short. 0.53. 